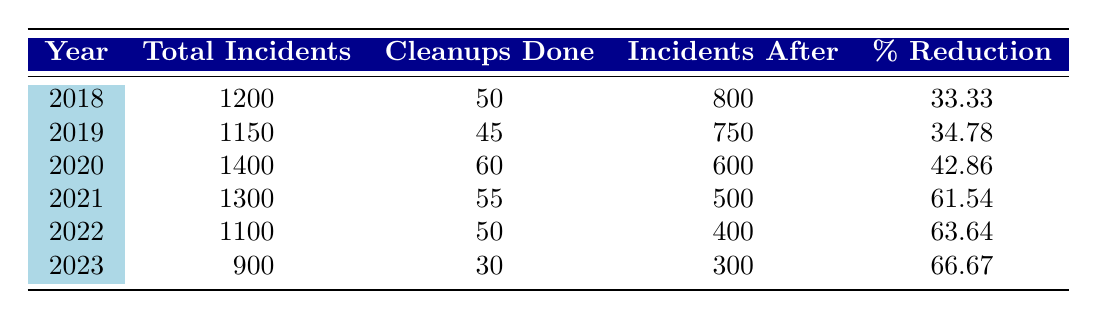What's the total number of graffiti incidents in 2020? According to the table, the total number of graffiti incidents in 2020 is listed as 1400.
Answer: 1400 What was the percentage reduction in graffiti incidents from 2018 to 2021? To find the percentage reduction, observe the total incidents in 2018 (1200) and in 2021 (1300). The percentage reduction can be calculated as (1200 - 500) / 1200 * 100 = 58.33. However, the data shows a reduction from 1200 to 500, giving a reduction of 61.54%.
Answer: 61.54 How many cleanups were done in the year with the highest percentage reduction? The year with the highest percentage reduction is 2023, which shows a reduction of 66.67%. According to the table, 30 cleanups were done that year.
Answer: 30 Was there an increase or decrease in total graffiti incidents from 2019 to 2020? In 2019 the total incidents were 1150 and in 2020 it was 1400. Since 1400 is greater than 1150, this indicates an increase in total incidents from 2019 to 2020.
Answer: Increase What is the average number of cleanups done per year from 2018 to 2023? To find the average number of cleanups, sum the cleanups from each year: (50 + 45 + 60 + 55 + 50 + 30 = 290). There are 6 years, so divide 290 by 6, yielding an average of approximately 48.33.
Answer: 48.33 What was the lowest number of incidents after cleanup and in what year did it occur? The lowest number of incidents after cleanup is 300, which occurred in the year 2023. This can be found by observing the incidents after cleanup for each year in the table.
Answer: 300 in 2023 If we compare the total incidents from 2023 to 2020, what is the difference? The total incidents in 2023 is 900 and in 2020 it is 1400. The difference is calculated as 1400 - 900 = 500.
Answer: 500 Did the percentage reduction improve every year from 2018 to 2023? Evaluating the percentage reductions: 33.33, 34.78, 42.86, 61.54, 63.64, and 66.67 shows that it did improve every year.
Answer: Yes How many total incidents were recorded from the years 2018 to 2022? To find the total incidents from 2018 to 2022, sum the incidents: (1200 + 1150 + 1400 + 1300 + 1100 = 5150).
Answer: 5150 